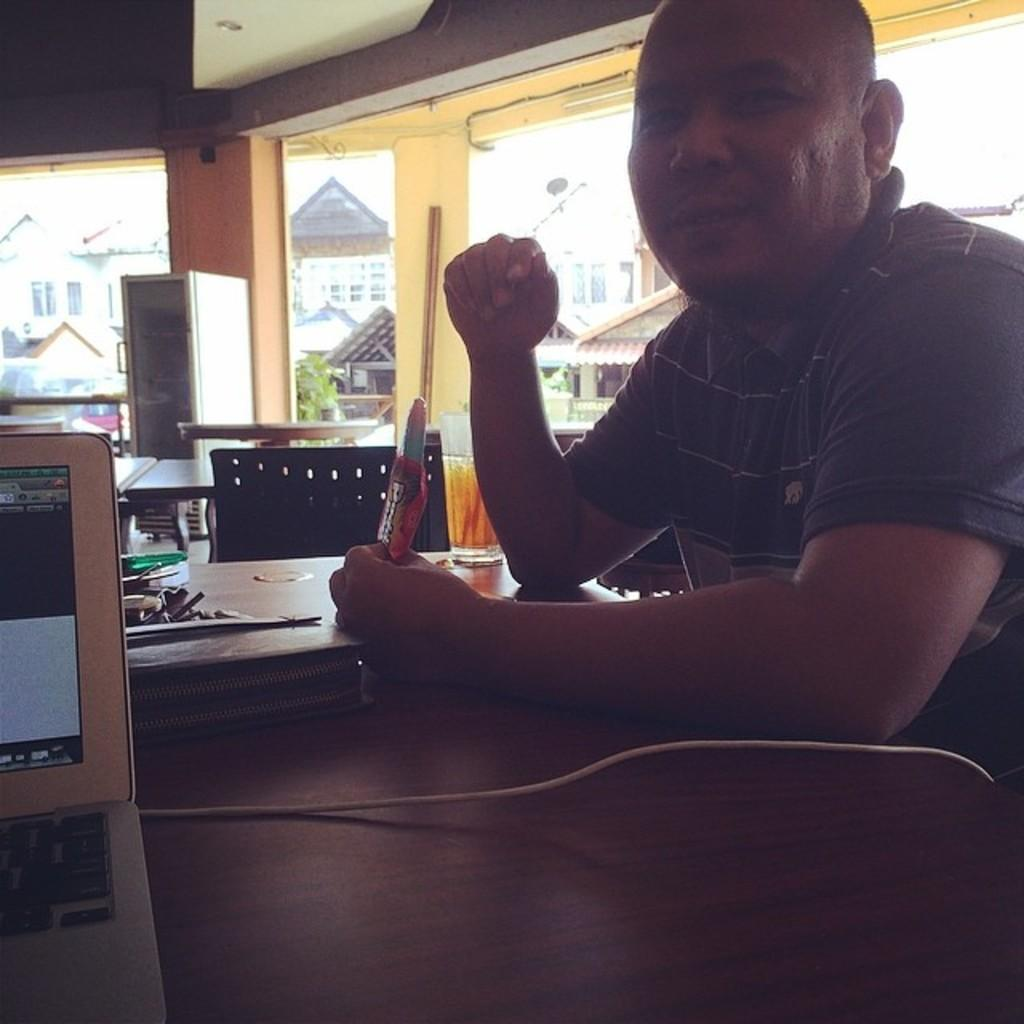Who is present in the image? There is a man in the image. What is the man doing in the image? The man is sitting on a chair. What objects are on the table in the image? There is a laptop and a glass on the table. What can be seen in the background of the image? There are houses in the background of the image. What advice does the man's grandmother give him in the image? There is no mention of a grandmother or any advice-giving in the image. What type of care is the man providing for the quince tree in the image? There is no quince tree or any indication of care-giving in the image. 